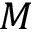Convert formula to latex. <formula><loc_0><loc_0><loc_500><loc_500>M</formula> 